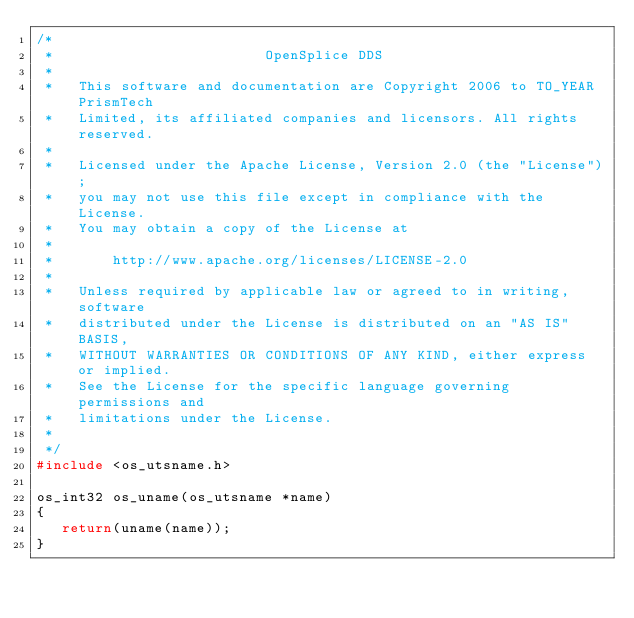Convert code to text. <code><loc_0><loc_0><loc_500><loc_500><_C_>/*
 *                         OpenSplice DDS
 *
 *   This software and documentation are Copyright 2006 to TO_YEAR PrismTech
 *   Limited, its affiliated companies and licensors. All rights reserved.
 *
 *   Licensed under the Apache License, Version 2.0 (the "License");
 *   you may not use this file except in compliance with the License.
 *   You may obtain a copy of the License at
 *
 *       http://www.apache.org/licenses/LICENSE-2.0
 *
 *   Unless required by applicable law or agreed to in writing, software
 *   distributed under the License is distributed on an "AS IS" BASIS,
 *   WITHOUT WARRANTIES OR CONDITIONS OF ANY KIND, either express or implied.
 *   See the License for the specific language governing permissions and
 *   limitations under the License.
 *
 */
#include <os_utsname.h>

os_int32 os_uname(os_utsname *name)
{
   return(uname(name));
}
</code> 